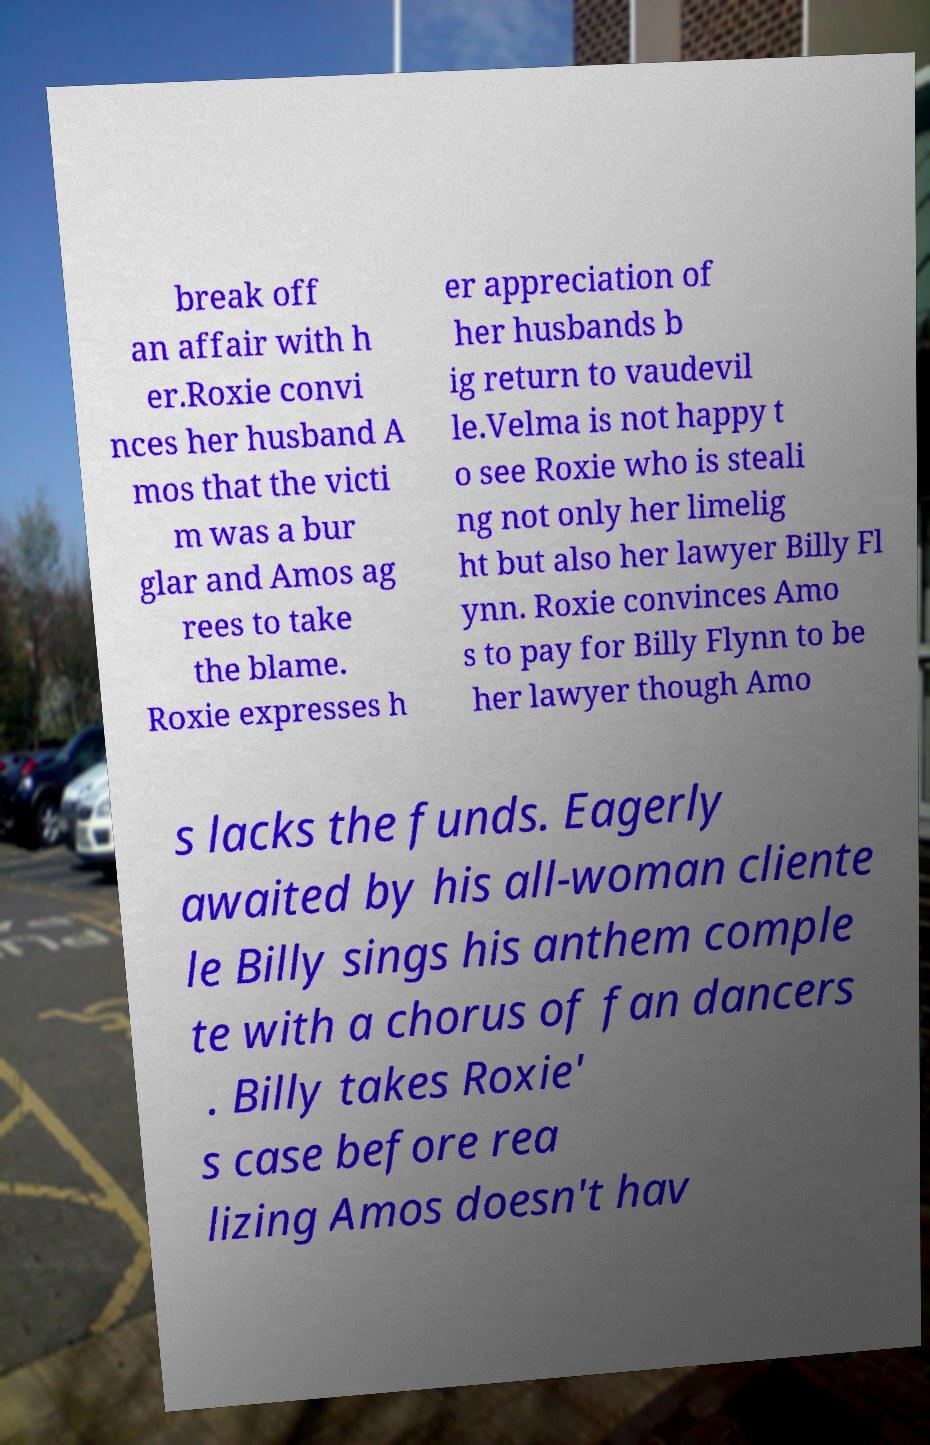For documentation purposes, I need the text within this image transcribed. Could you provide that? break off an affair with h er.Roxie convi nces her husband A mos that the victi m was a bur glar and Amos ag rees to take the blame. Roxie expresses h er appreciation of her husbands b ig return to vaudevil le.Velma is not happy t o see Roxie who is steali ng not only her limelig ht but also her lawyer Billy Fl ynn. Roxie convinces Amo s to pay for Billy Flynn to be her lawyer though Amo s lacks the funds. Eagerly awaited by his all-woman cliente le Billy sings his anthem comple te with a chorus of fan dancers . Billy takes Roxie' s case before rea lizing Amos doesn't hav 